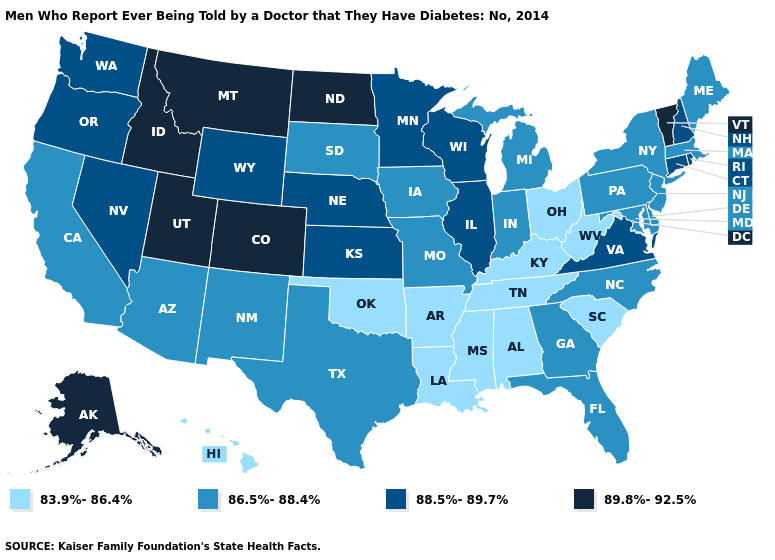Name the states that have a value in the range 88.5%-89.7%?
Concise answer only. Connecticut, Illinois, Kansas, Minnesota, Nebraska, Nevada, New Hampshire, Oregon, Rhode Island, Virginia, Washington, Wisconsin, Wyoming. What is the value of Louisiana?
Keep it brief. 83.9%-86.4%. How many symbols are there in the legend?
Short answer required. 4. Name the states that have a value in the range 83.9%-86.4%?
Short answer required. Alabama, Arkansas, Hawaii, Kentucky, Louisiana, Mississippi, Ohio, Oklahoma, South Carolina, Tennessee, West Virginia. How many symbols are there in the legend?
Keep it brief. 4. What is the highest value in states that border Colorado?
Be succinct. 89.8%-92.5%. Name the states that have a value in the range 88.5%-89.7%?
Be succinct. Connecticut, Illinois, Kansas, Minnesota, Nebraska, Nevada, New Hampshire, Oregon, Rhode Island, Virginia, Washington, Wisconsin, Wyoming. What is the value of Texas?
Short answer required. 86.5%-88.4%. What is the lowest value in states that border New York?
Give a very brief answer. 86.5%-88.4%. Does Arkansas have the lowest value in the USA?
Keep it brief. Yes. Does the map have missing data?
Concise answer only. No. Does Indiana have the lowest value in the MidWest?
Keep it brief. No. Does Massachusetts have the highest value in the USA?
Be succinct. No. Which states have the lowest value in the MidWest?
Quick response, please. Ohio. What is the value of Alabama?
Quick response, please. 83.9%-86.4%. 